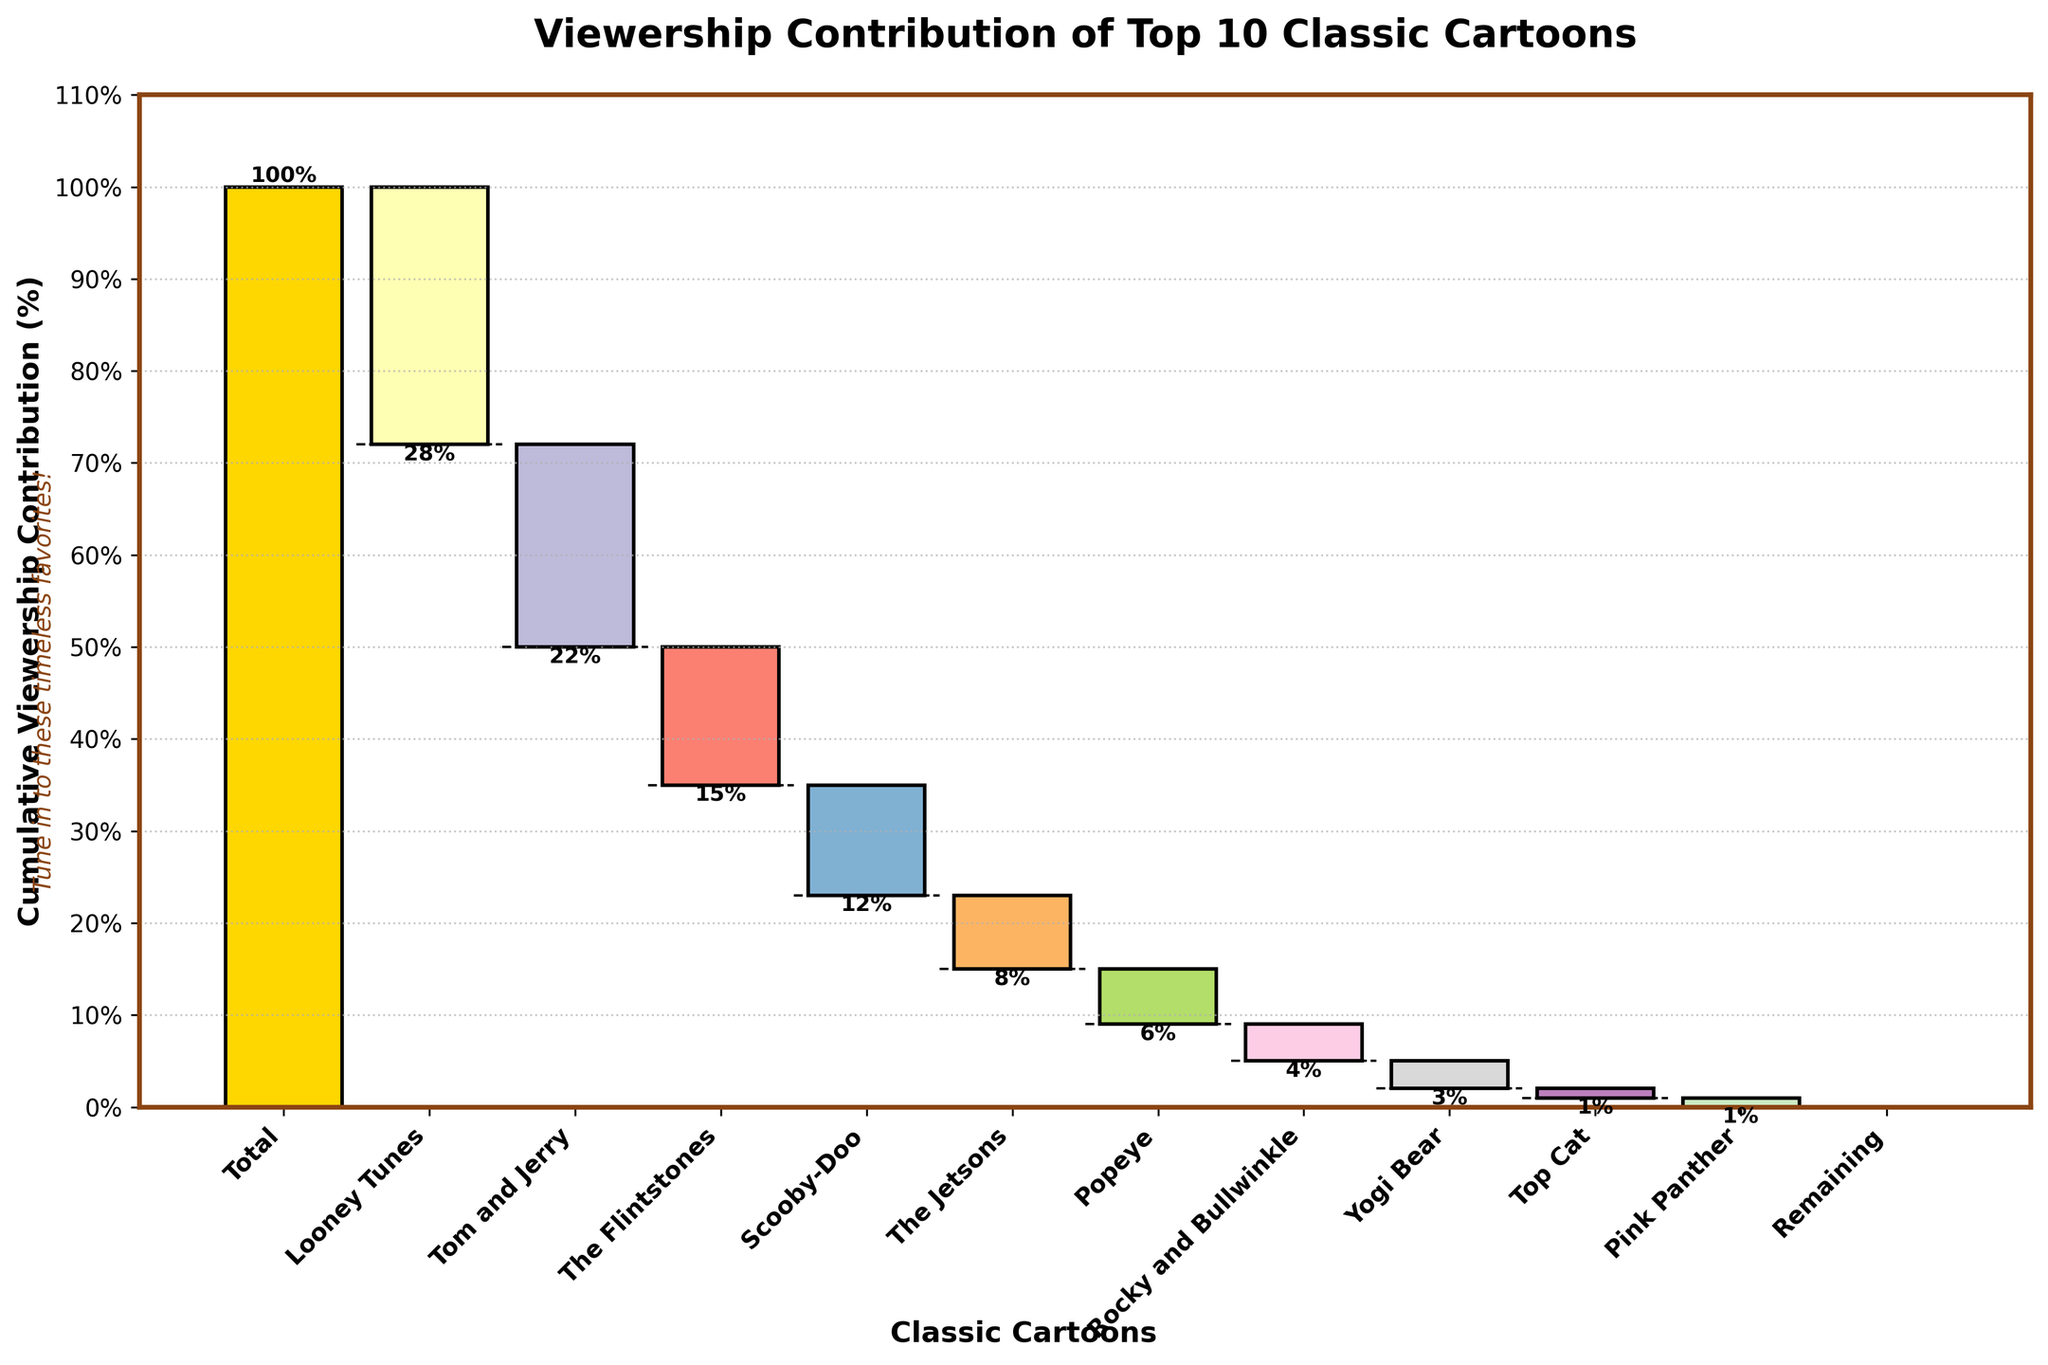What is the total viewership contribution represented in the chart? The first bar in the chart shows the "Total" viewership contribution, listed as 100%. This represents the cumulative contribution from all the cartoons combined.
Answer: 100% Which cartoon has the highest negative contribution to viewership? Looking at the chart, "Looney Tunes" has the largest drop from the total, indicating the highest negative contribution to viewership with -28%.
Answer: Looney Tunes Which cartoon contributes the least to the viewership, and what is its percentage? The cartoon with the smallest negative impact is "Pink Panther," which shows -1%, the smallest decrease apart from "Top Cat," which also shows -1%. They both have the smallest individual contributions.
Answer: Pink Panther or Top Cat, -1% What is the cumulative viewership percentage after "Popeye"? The cumulative percentage after "Popeye" can be calculated by adding its contribution to the previous cumulative sums (-28 + -22 + -15 + -12 + -8 + -6 = -91%). However, since the graph measures from the top down, the actual cumulative viewership at this point would be 9%.
Answer: 9% What are the colors used to represent the "Total" and "Remaining" contributions? The "Total" contribution bar is generally colored gold, while the "Remaining" contribution bar is green. This helps distinguish these bars from the others.
Answer: Gold (Total), Green (Remaining) What is the overall contribution of "Scooby-Doo" plus "The Jetsons" plus "Popeye"? Adding these three contributions: -12% (Scooby-Doo) + -8% (The Jetsons) + -6% (Popeye) gives -12 - 8 - 6 = -26%.
Answer: -26% What does the "Remaining" bar signify? The "Remaining" bar signifies that there are no more contributions to be added or subtracted, indicating all data points have been accounted for and cumulative contributions result in zero change beyond "Remaining."
Answer: No more changes in viewership contribution 